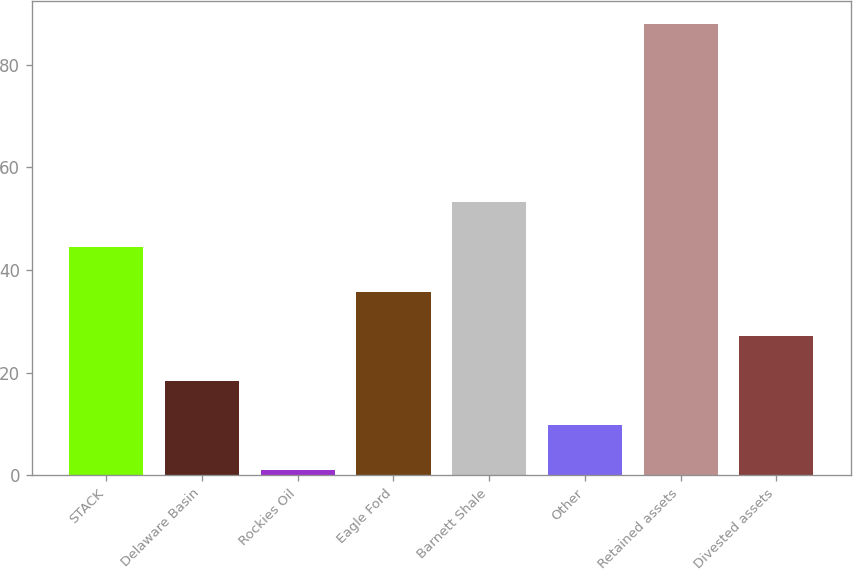Convert chart to OTSL. <chart><loc_0><loc_0><loc_500><loc_500><bar_chart><fcel>STACK<fcel>Delaware Basin<fcel>Rockies Oil<fcel>Eagle Ford<fcel>Barnett Shale<fcel>Other<fcel>Retained assets<fcel>Divested assets<nl><fcel>44.5<fcel>18.4<fcel>1<fcel>35.8<fcel>53.2<fcel>9.7<fcel>88<fcel>27.1<nl></chart> 